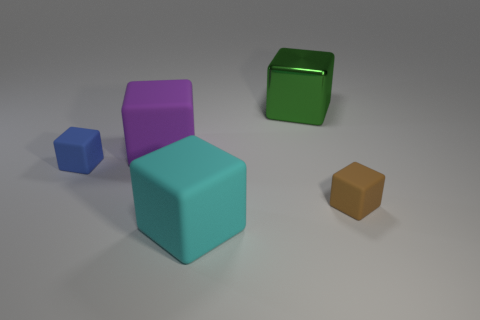The green shiny cube has what size?
Provide a short and direct response. Large. There is a green metallic block; is it the same size as the cyan matte thing to the left of the brown rubber thing?
Make the answer very short. Yes. How many brown things are either metallic things or large things?
Ensure brevity in your answer.  0. What number of green shiny objects are there?
Offer a very short reply. 1. What size is the matte object left of the big purple cube?
Give a very brief answer. Small. Do the brown cube and the blue rubber cube have the same size?
Your answer should be compact. Yes. How many objects are green things or large rubber things that are in front of the blue rubber block?
Offer a very short reply. 2. What is the material of the blue thing?
Offer a terse response. Rubber. Are there any other things of the same color as the metallic cube?
Give a very brief answer. No. Does the cyan rubber thing have the same shape as the metal thing?
Provide a succinct answer. Yes. 